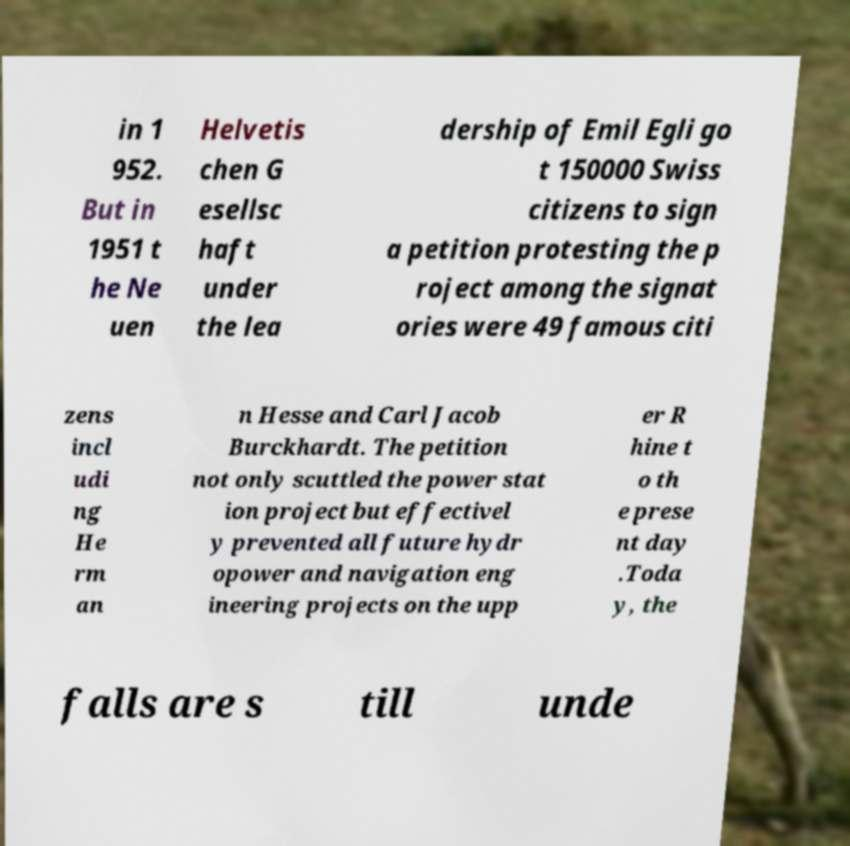Please read and relay the text visible in this image. What does it say? in 1 952. But in 1951 t he Ne uen Helvetis chen G esellsc haft under the lea dership of Emil Egli go t 150000 Swiss citizens to sign a petition protesting the p roject among the signat ories were 49 famous citi zens incl udi ng He rm an n Hesse and Carl Jacob Burckhardt. The petition not only scuttled the power stat ion project but effectivel y prevented all future hydr opower and navigation eng ineering projects on the upp er R hine t o th e prese nt day .Toda y, the falls are s till unde 